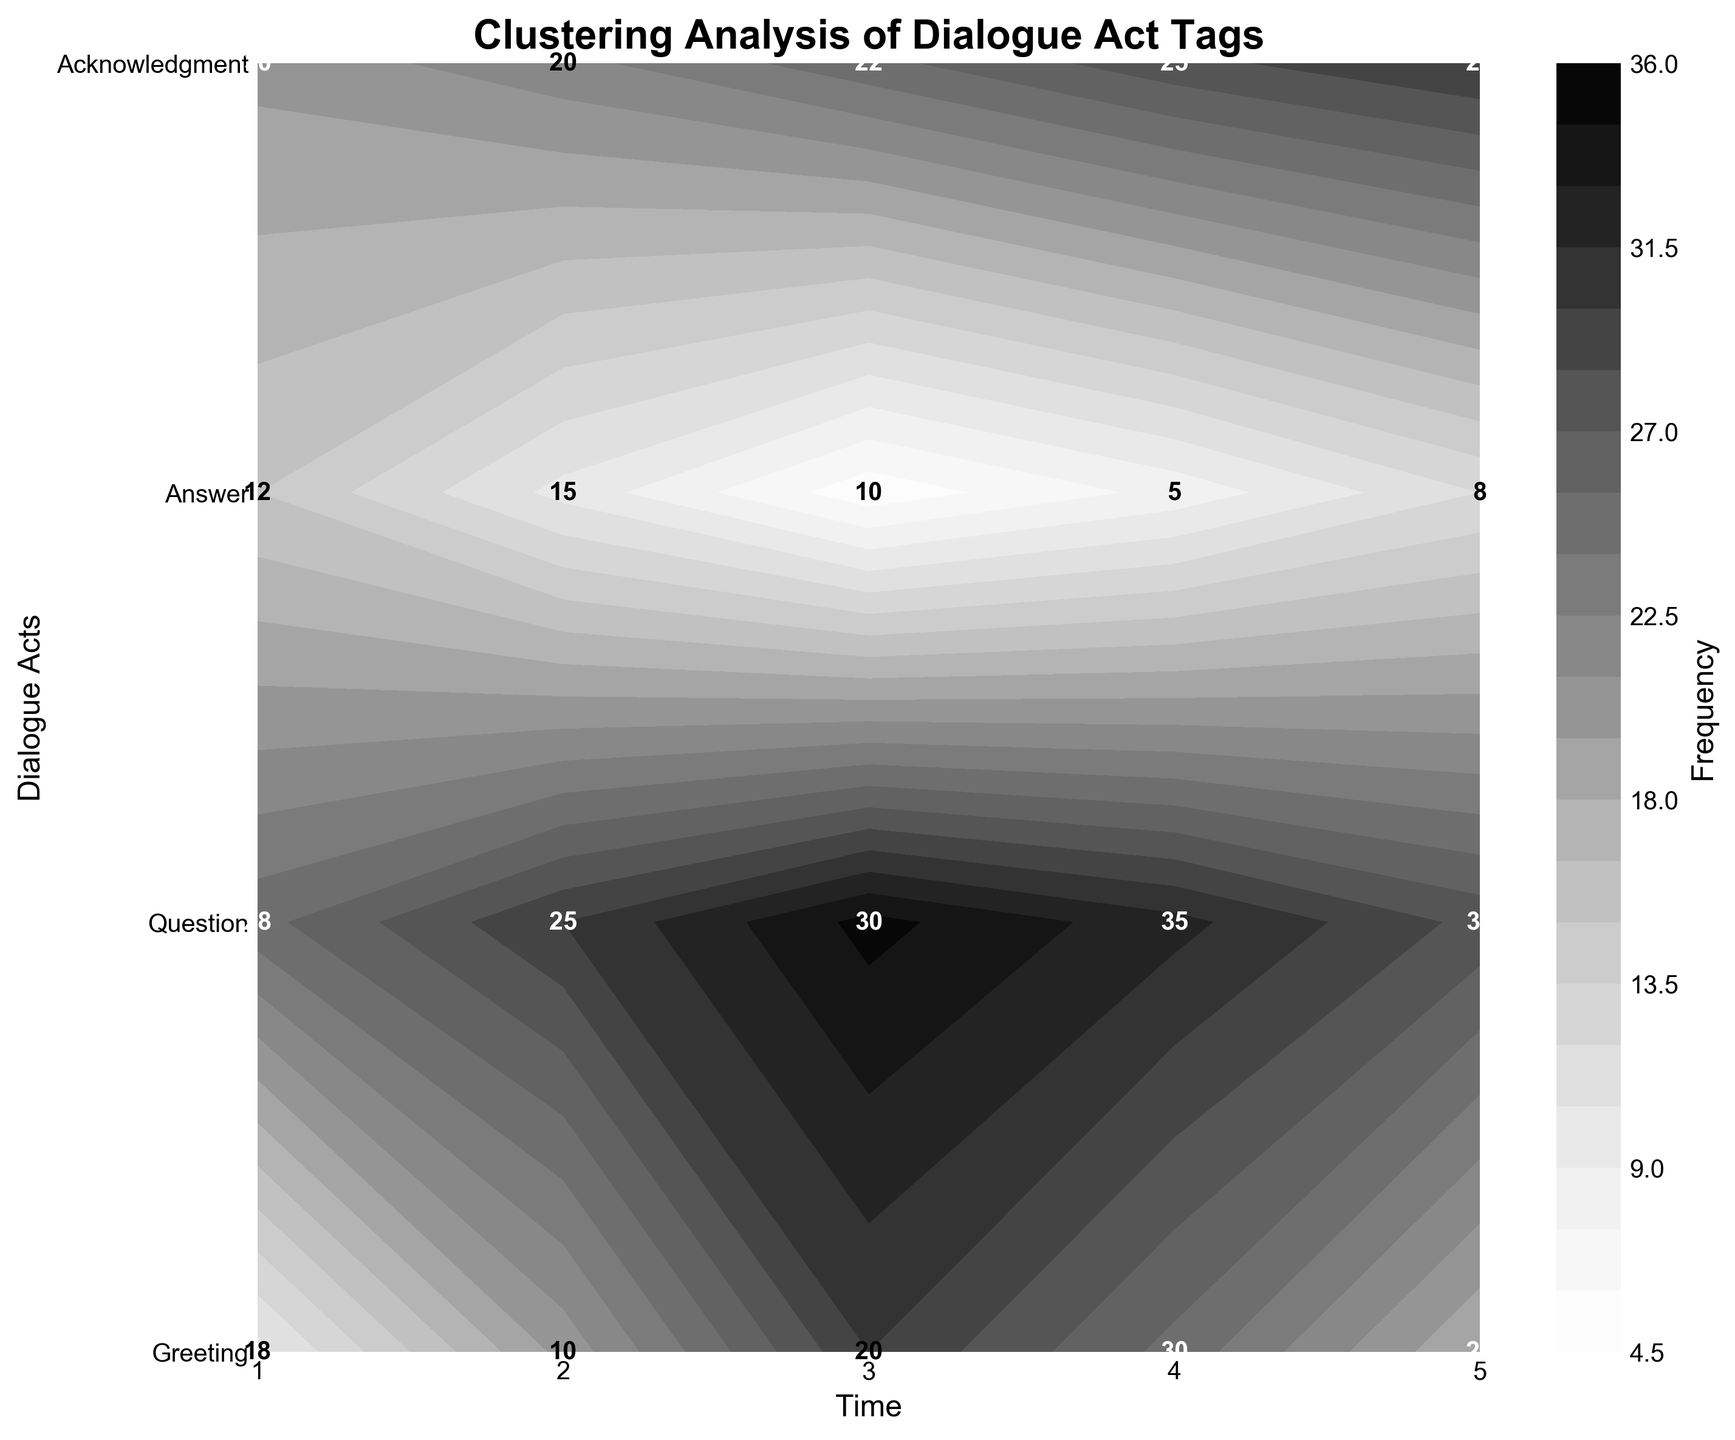What is the title of the figure? The title is displayed at the top of the figure and provides a brief summary of what the figure represents.
Answer: Clustering Analysis of Dialogue Act Tags How many dialogue act types are plotted? Count the unique labels on the y-axis, which represent different dialogue act types.
Answer: 4 At which time point is the frequency of the 'Answer' dialogue act the highest? Find the contour plot segment corresponding to the 'Answer' dialogue act and identify the time point where the frequency number is the highest.
Answer: 3 Which dialogue act has a steady increase in frequency over the time points? Observe the frequency annotations for each dialogue act; 'Question' shows an increasing trend from time point 1 to time point 5.
Answer: Question Compare the frequency of 'Acknowledgment' between time points 2 and 4. Which time point has a higher frequency? Locate the 'Acknowledgment' dialogue act on the contour plot and compare its frequency at time points 2 and 4.
Answer: 4 What is the average frequency of the 'Greeting' dialogue act over all time points? Sum the frequencies of the 'Greeting' dialogue act at each time point (15 + 10 + 5 + 8 + 12) and divide by the number of time points (5).
Answer: 10 Which dialogue act shows the greatest change in frequency between any two consecutive time points? Calculate the absolute differences in frequencies between consecutive time points for each dialogue act. The 'Acknowledgment' dialogue act has the greatest change (30 - 10 = 20) between time points 1 and 2.
Answer: Acknowledgment Is there any dialogue act that has a lower frequency in the last time point compared to the first time point? Compare the frequencies of each dialogue act at the first and last time points. The frequency of the 'Answer' dialogue act decreases from 1 to 5 (25 to 28).
Answer: No 